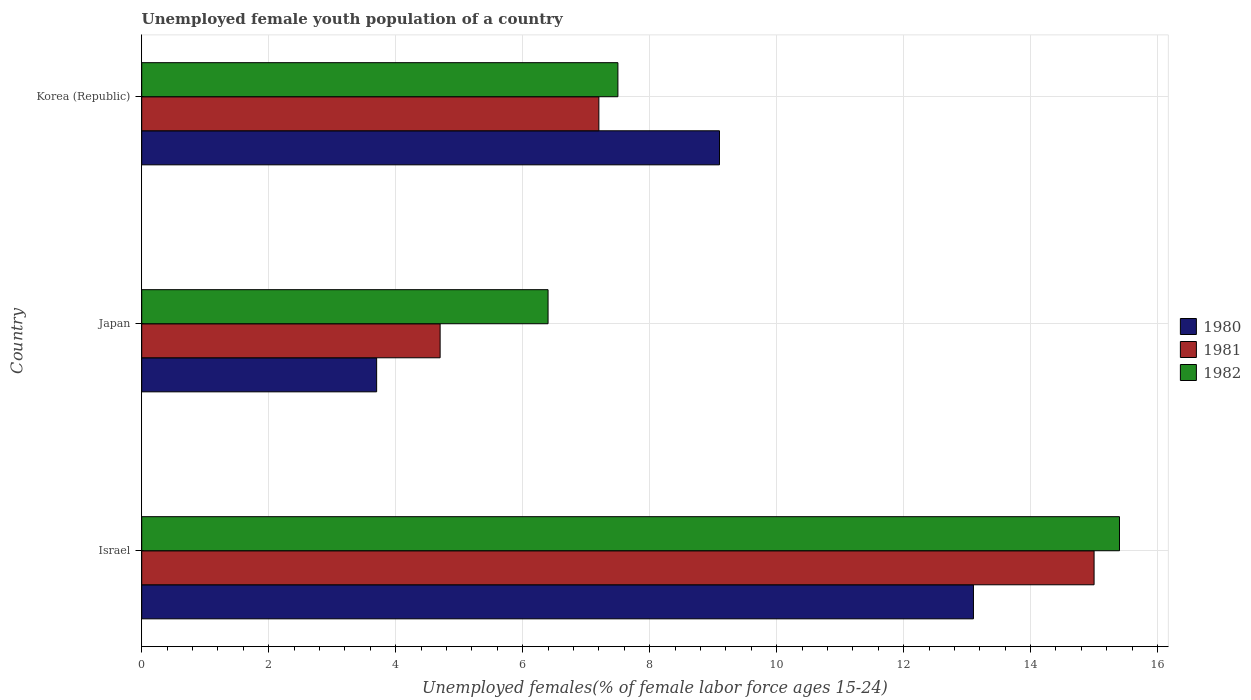Are the number of bars per tick equal to the number of legend labels?
Give a very brief answer. Yes. How many bars are there on the 2nd tick from the top?
Keep it short and to the point. 3. How many bars are there on the 1st tick from the bottom?
Provide a short and direct response. 3. What is the percentage of unemployed female youth population in 1981 in Korea (Republic)?
Keep it short and to the point. 7.2. Across all countries, what is the maximum percentage of unemployed female youth population in 1981?
Keep it short and to the point. 15. Across all countries, what is the minimum percentage of unemployed female youth population in 1980?
Provide a short and direct response. 3.7. In which country was the percentage of unemployed female youth population in 1980 maximum?
Keep it short and to the point. Israel. In which country was the percentage of unemployed female youth population in 1982 minimum?
Provide a succinct answer. Japan. What is the total percentage of unemployed female youth population in 1980 in the graph?
Your response must be concise. 25.9. What is the difference between the percentage of unemployed female youth population in 1980 in Israel and that in Japan?
Provide a short and direct response. 9.4. What is the difference between the percentage of unemployed female youth population in 1981 in Japan and the percentage of unemployed female youth population in 1980 in Korea (Republic)?
Offer a terse response. -4.4. What is the average percentage of unemployed female youth population in 1980 per country?
Your response must be concise. 8.63. What is the difference between the percentage of unemployed female youth population in 1982 and percentage of unemployed female youth population in 1981 in Korea (Republic)?
Your response must be concise. 0.3. What is the ratio of the percentage of unemployed female youth population in 1982 in Israel to that in Korea (Republic)?
Your answer should be compact. 2.05. Is the difference between the percentage of unemployed female youth population in 1982 in Japan and Korea (Republic) greater than the difference between the percentage of unemployed female youth population in 1981 in Japan and Korea (Republic)?
Keep it short and to the point. Yes. What is the difference between the highest and the second highest percentage of unemployed female youth population in 1981?
Make the answer very short. 7.8. What is the difference between the highest and the lowest percentage of unemployed female youth population in 1982?
Give a very brief answer. 9. What does the 2nd bar from the top in Korea (Republic) represents?
Give a very brief answer. 1981. What does the 2nd bar from the bottom in Korea (Republic) represents?
Your answer should be very brief. 1981. What is the difference between two consecutive major ticks on the X-axis?
Your answer should be very brief. 2. Does the graph contain any zero values?
Provide a succinct answer. No. How many legend labels are there?
Provide a succinct answer. 3. How are the legend labels stacked?
Give a very brief answer. Vertical. What is the title of the graph?
Keep it short and to the point. Unemployed female youth population of a country. What is the label or title of the X-axis?
Ensure brevity in your answer.  Unemployed females(% of female labor force ages 15-24). What is the label or title of the Y-axis?
Provide a succinct answer. Country. What is the Unemployed females(% of female labor force ages 15-24) in 1980 in Israel?
Offer a terse response. 13.1. What is the Unemployed females(% of female labor force ages 15-24) in 1981 in Israel?
Offer a terse response. 15. What is the Unemployed females(% of female labor force ages 15-24) of 1982 in Israel?
Make the answer very short. 15.4. What is the Unemployed females(% of female labor force ages 15-24) in 1980 in Japan?
Provide a short and direct response. 3.7. What is the Unemployed females(% of female labor force ages 15-24) of 1981 in Japan?
Your answer should be very brief. 4.7. What is the Unemployed females(% of female labor force ages 15-24) of 1982 in Japan?
Offer a terse response. 6.4. What is the Unemployed females(% of female labor force ages 15-24) in 1980 in Korea (Republic)?
Offer a very short reply. 9.1. What is the Unemployed females(% of female labor force ages 15-24) in 1981 in Korea (Republic)?
Offer a terse response. 7.2. Across all countries, what is the maximum Unemployed females(% of female labor force ages 15-24) in 1980?
Offer a very short reply. 13.1. Across all countries, what is the maximum Unemployed females(% of female labor force ages 15-24) in 1981?
Make the answer very short. 15. Across all countries, what is the maximum Unemployed females(% of female labor force ages 15-24) of 1982?
Your answer should be compact. 15.4. Across all countries, what is the minimum Unemployed females(% of female labor force ages 15-24) of 1980?
Provide a succinct answer. 3.7. Across all countries, what is the minimum Unemployed females(% of female labor force ages 15-24) of 1981?
Ensure brevity in your answer.  4.7. Across all countries, what is the minimum Unemployed females(% of female labor force ages 15-24) of 1982?
Keep it short and to the point. 6.4. What is the total Unemployed females(% of female labor force ages 15-24) in 1980 in the graph?
Your answer should be very brief. 25.9. What is the total Unemployed females(% of female labor force ages 15-24) of 1981 in the graph?
Give a very brief answer. 26.9. What is the total Unemployed females(% of female labor force ages 15-24) of 1982 in the graph?
Your response must be concise. 29.3. What is the difference between the Unemployed females(% of female labor force ages 15-24) in 1980 in Japan and that in Korea (Republic)?
Ensure brevity in your answer.  -5.4. What is the difference between the Unemployed females(% of female labor force ages 15-24) of 1981 in Japan and that in Korea (Republic)?
Your answer should be compact. -2.5. What is the difference between the Unemployed females(% of female labor force ages 15-24) of 1981 in Israel and the Unemployed females(% of female labor force ages 15-24) of 1982 in Japan?
Provide a succinct answer. 8.6. What is the difference between the Unemployed females(% of female labor force ages 15-24) in 1980 in Israel and the Unemployed females(% of female labor force ages 15-24) in 1982 in Korea (Republic)?
Provide a short and direct response. 5.6. What is the difference between the Unemployed females(% of female labor force ages 15-24) of 1981 in Israel and the Unemployed females(% of female labor force ages 15-24) of 1982 in Korea (Republic)?
Provide a short and direct response. 7.5. What is the difference between the Unemployed females(% of female labor force ages 15-24) of 1980 in Japan and the Unemployed females(% of female labor force ages 15-24) of 1982 in Korea (Republic)?
Provide a succinct answer. -3.8. What is the difference between the Unemployed females(% of female labor force ages 15-24) of 1981 in Japan and the Unemployed females(% of female labor force ages 15-24) of 1982 in Korea (Republic)?
Make the answer very short. -2.8. What is the average Unemployed females(% of female labor force ages 15-24) in 1980 per country?
Your response must be concise. 8.63. What is the average Unemployed females(% of female labor force ages 15-24) in 1981 per country?
Your answer should be compact. 8.97. What is the average Unemployed females(% of female labor force ages 15-24) in 1982 per country?
Provide a short and direct response. 9.77. What is the difference between the Unemployed females(% of female labor force ages 15-24) of 1980 and Unemployed females(% of female labor force ages 15-24) of 1981 in Israel?
Ensure brevity in your answer.  -1.9. What is the difference between the Unemployed females(% of female labor force ages 15-24) in 1980 and Unemployed females(% of female labor force ages 15-24) in 1982 in Israel?
Provide a short and direct response. -2.3. What is the difference between the Unemployed females(% of female labor force ages 15-24) of 1981 and Unemployed females(% of female labor force ages 15-24) of 1982 in Korea (Republic)?
Your response must be concise. -0.3. What is the ratio of the Unemployed females(% of female labor force ages 15-24) in 1980 in Israel to that in Japan?
Ensure brevity in your answer.  3.54. What is the ratio of the Unemployed females(% of female labor force ages 15-24) in 1981 in Israel to that in Japan?
Keep it short and to the point. 3.19. What is the ratio of the Unemployed females(% of female labor force ages 15-24) in 1982 in Israel to that in Japan?
Provide a short and direct response. 2.41. What is the ratio of the Unemployed females(% of female labor force ages 15-24) in 1980 in Israel to that in Korea (Republic)?
Your answer should be compact. 1.44. What is the ratio of the Unemployed females(% of female labor force ages 15-24) in 1981 in Israel to that in Korea (Republic)?
Give a very brief answer. 2.08. What is the ratio of the Unemployed females(% of female labor force ages 15-24) of 1982 in Israel to that in Korea (Republic)?
Your answer should be very brief. 2.05. What is the ratio of the Unemployed females(% of female labor force ages 15-24) of 1980 in Japan to that in Korea (Republic)?
Give a very brief answer. 0.41. What is the ratio of the Unemployed females(% of female labor force ages 15-24) in 1981 in Japan to that in Korea (Republic)?
Offer a terse response. 0.65. What is the ratio of the Unemployed females(% of female labor force ages 15-24) of 1982 in Japan to that in Korea (Republic)?
Offer a very short reply. 0.85. What is the difference between the highest and the second highest Unemployed females(% of female labor force ages 15-24) of 1981?
Provide a short and direct response. 7.8. What is the difference between the highest and the lowest Unemployed females(% of female labor force ages 15-24) in 1980?
Give a very brief answer. 9.4. What is the difference between the highest and the lowest Unemployed females(% of female labor force ages 15-24) in 1981?
Make the answer very short. 10.3. What is the difference between the highest and the lowest Unemployed females(% of female labor force ages 15-24) in 1982?
Make the answer very short. 9. 